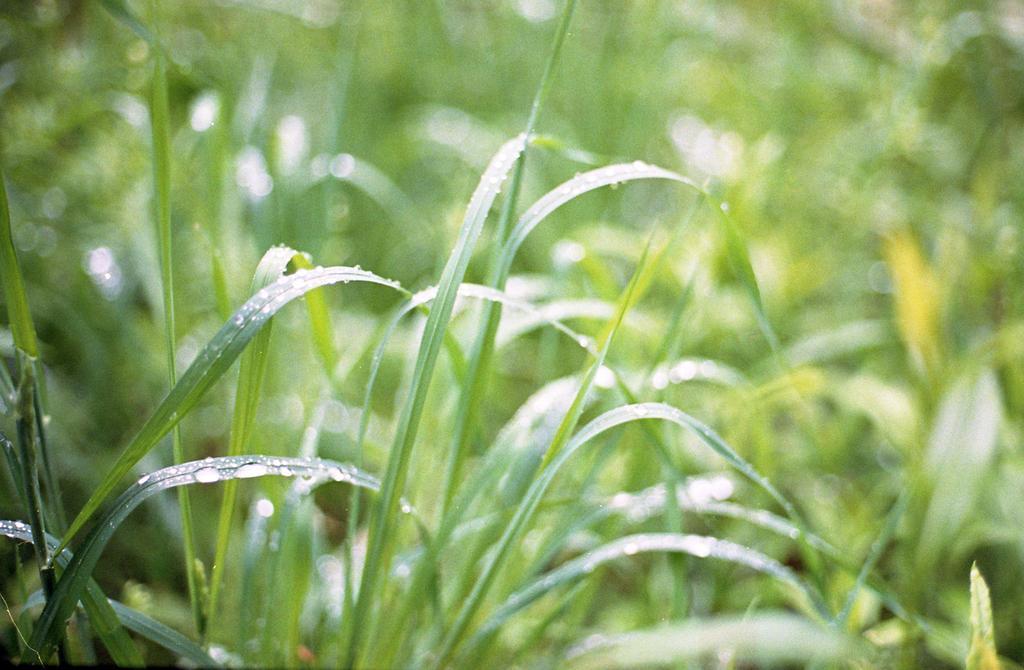Describe this image in one or two sentences. In this picture there is grass and there are water droplets on the grass. 